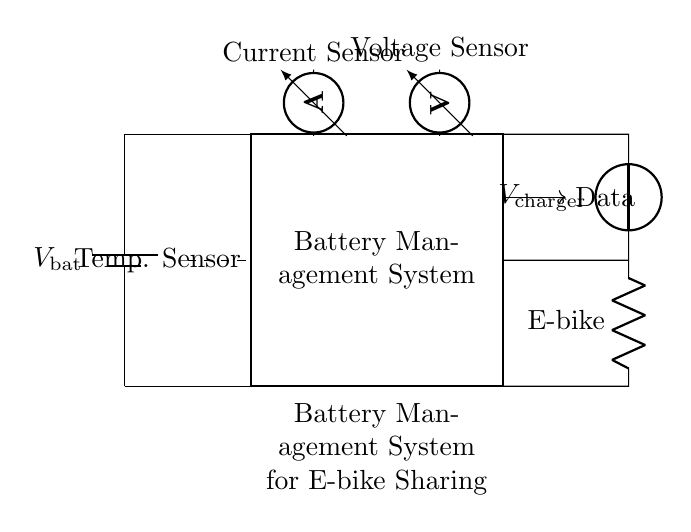What is the main component of this circuit? The main component is the battery management system, which is represented as a rectangle labeled "Battery Management System" in the circuit diagram.
Answer: Battery Management System What type of sensor is shown in this circuit? The circuit diagram incorporates a current sensor and a voltage sensor, which measure the respective electrical parameters of the circuit for monitoring.
Answer: Current and Voltage Sensors What is the voltage of the battery? The diagram represents the battery voltage as "V bat," indicating the battery's potential difference is a variable value that must be defined in the context of the specific circuit usage.
Answer: V bat How many sensors are employed in the circuit? The circuit features three different sensors: one current sensor, one voltage sensor, and one temperature sensor, indicated by their labels in the diagram.
Answer: Three sensors What type of load does this circuit support? The load connected to the circuit is specified as an "E-bike," illustrating that it is designed to power electric bicycles specifically.
Answer: E-bike How is the battery management system powered? The battery management system is powered by connecting the battery directly to it, allowing it to manage the energy distribution from the battery to the load (E-bike).
Answer: Directly from the battery What does the dashed line represent in this circuit? The dashed line denotes the temperature sensor, indicating that it is a component that monitors temperature but is not connected directly with wires in the same manner as the other sensors.
Answer: Temperature Sensor 